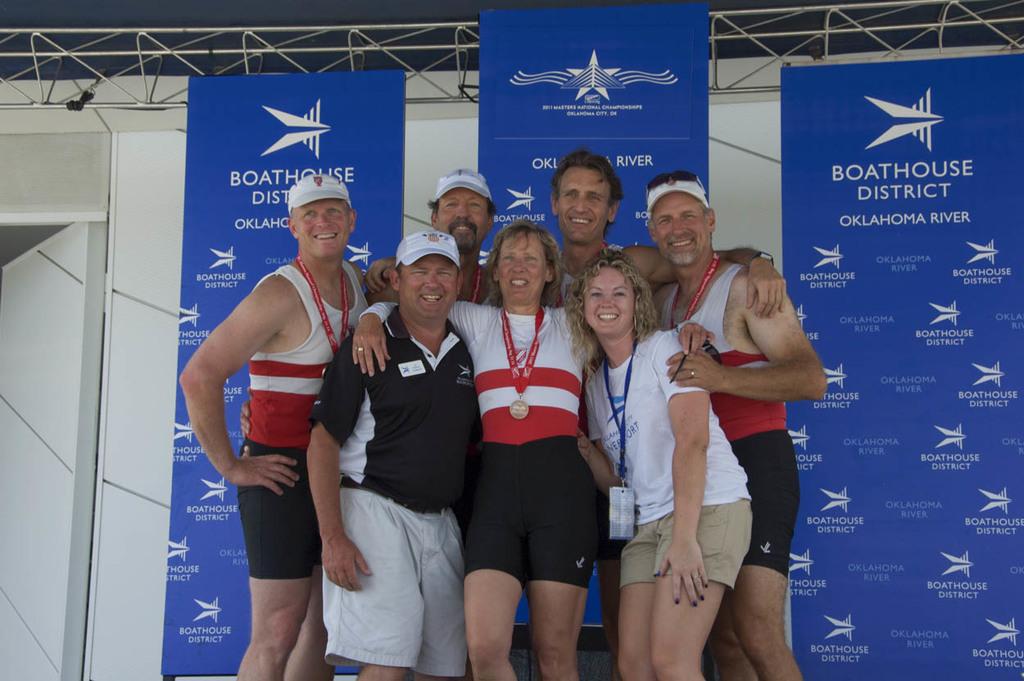What district are they in?
Make the answer very short. Boathouse. 